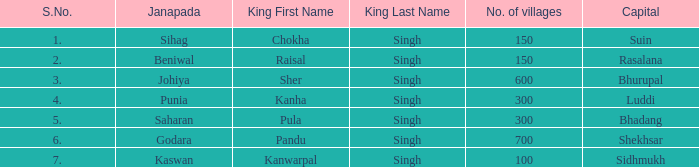What king has an S. number over 1 and a number of villages of 600? Sher Singh. 